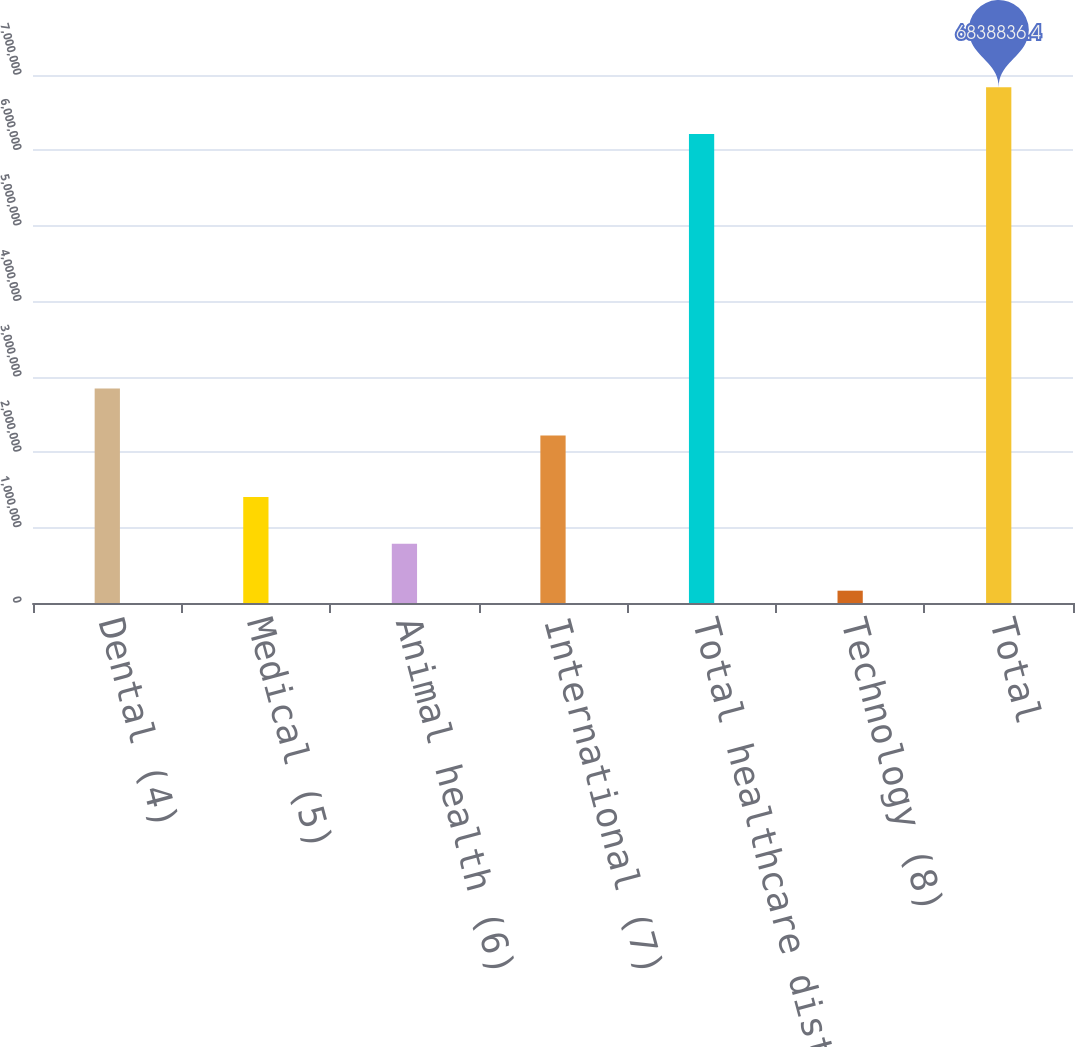Convert chart to OTSL. <chart><loc_0><loc_0><loc_500><loc_500><bar_chart><fcel>Dental (4)<fcel>Medical (5)<fcel>Animal health (6)<fcel>International (7)<fcel>Total healthcare distribution<fcel>Technology (8)<fcel>Total<nl><fcel>2.8428e+06<fcel>1.40671e+06<fcel>785001<fcel>2.22109e+06<fcel>6.21712e+06<fcel>163289<fcel>6.83884e+06<nl></chart> 